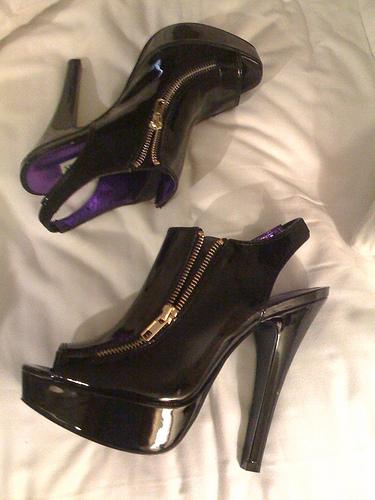Would these shoes be comfortable to wear?
Concise answer only. No. Is this a ladies shoe?
Give a very brief answer. Yes. What color is the shoe lining?
Write a very short answer. Purple. 